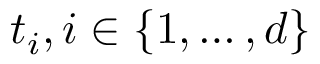<formula> <loc_0><loc_0><loc_500><loc_500>t _ { i } , i \in \{ 1 , \dots , d \}</formula> 